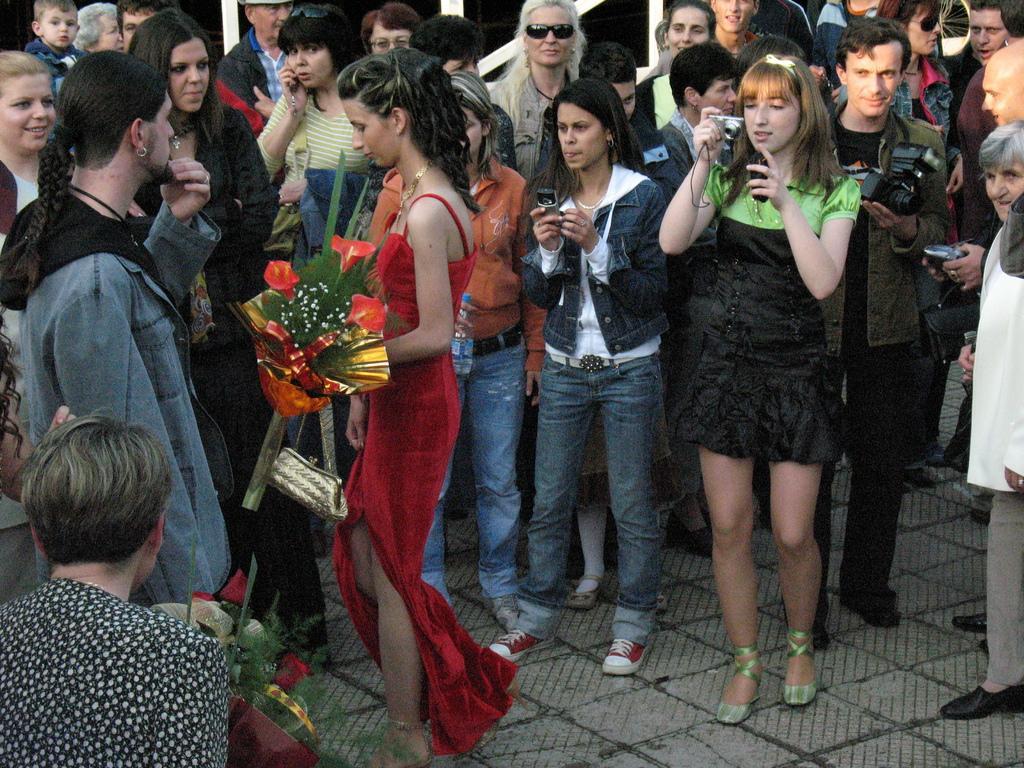How would you summarize this image in a sentence or two? In this picture I can observe some people standing on the land. There are men and women in this picture. Some of them are holding cameras in their hands. 